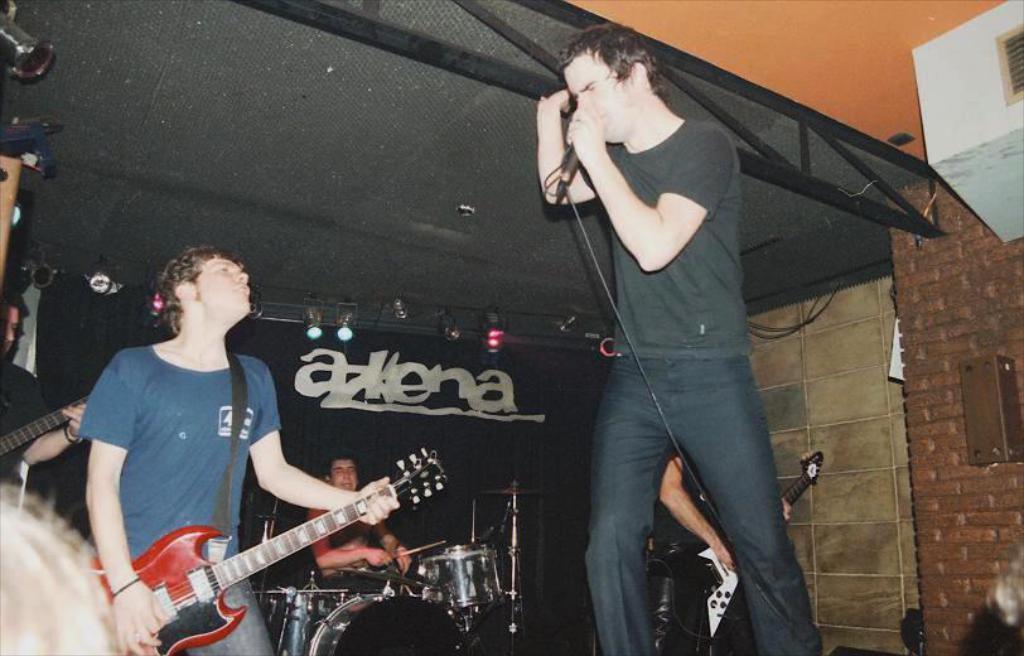Please provide a concise description of this image. On the stage we can find few people one man is holding a microphone in his hand singing a song and one man is holding guitar. In the background we can find lights and ceiling and wall. 